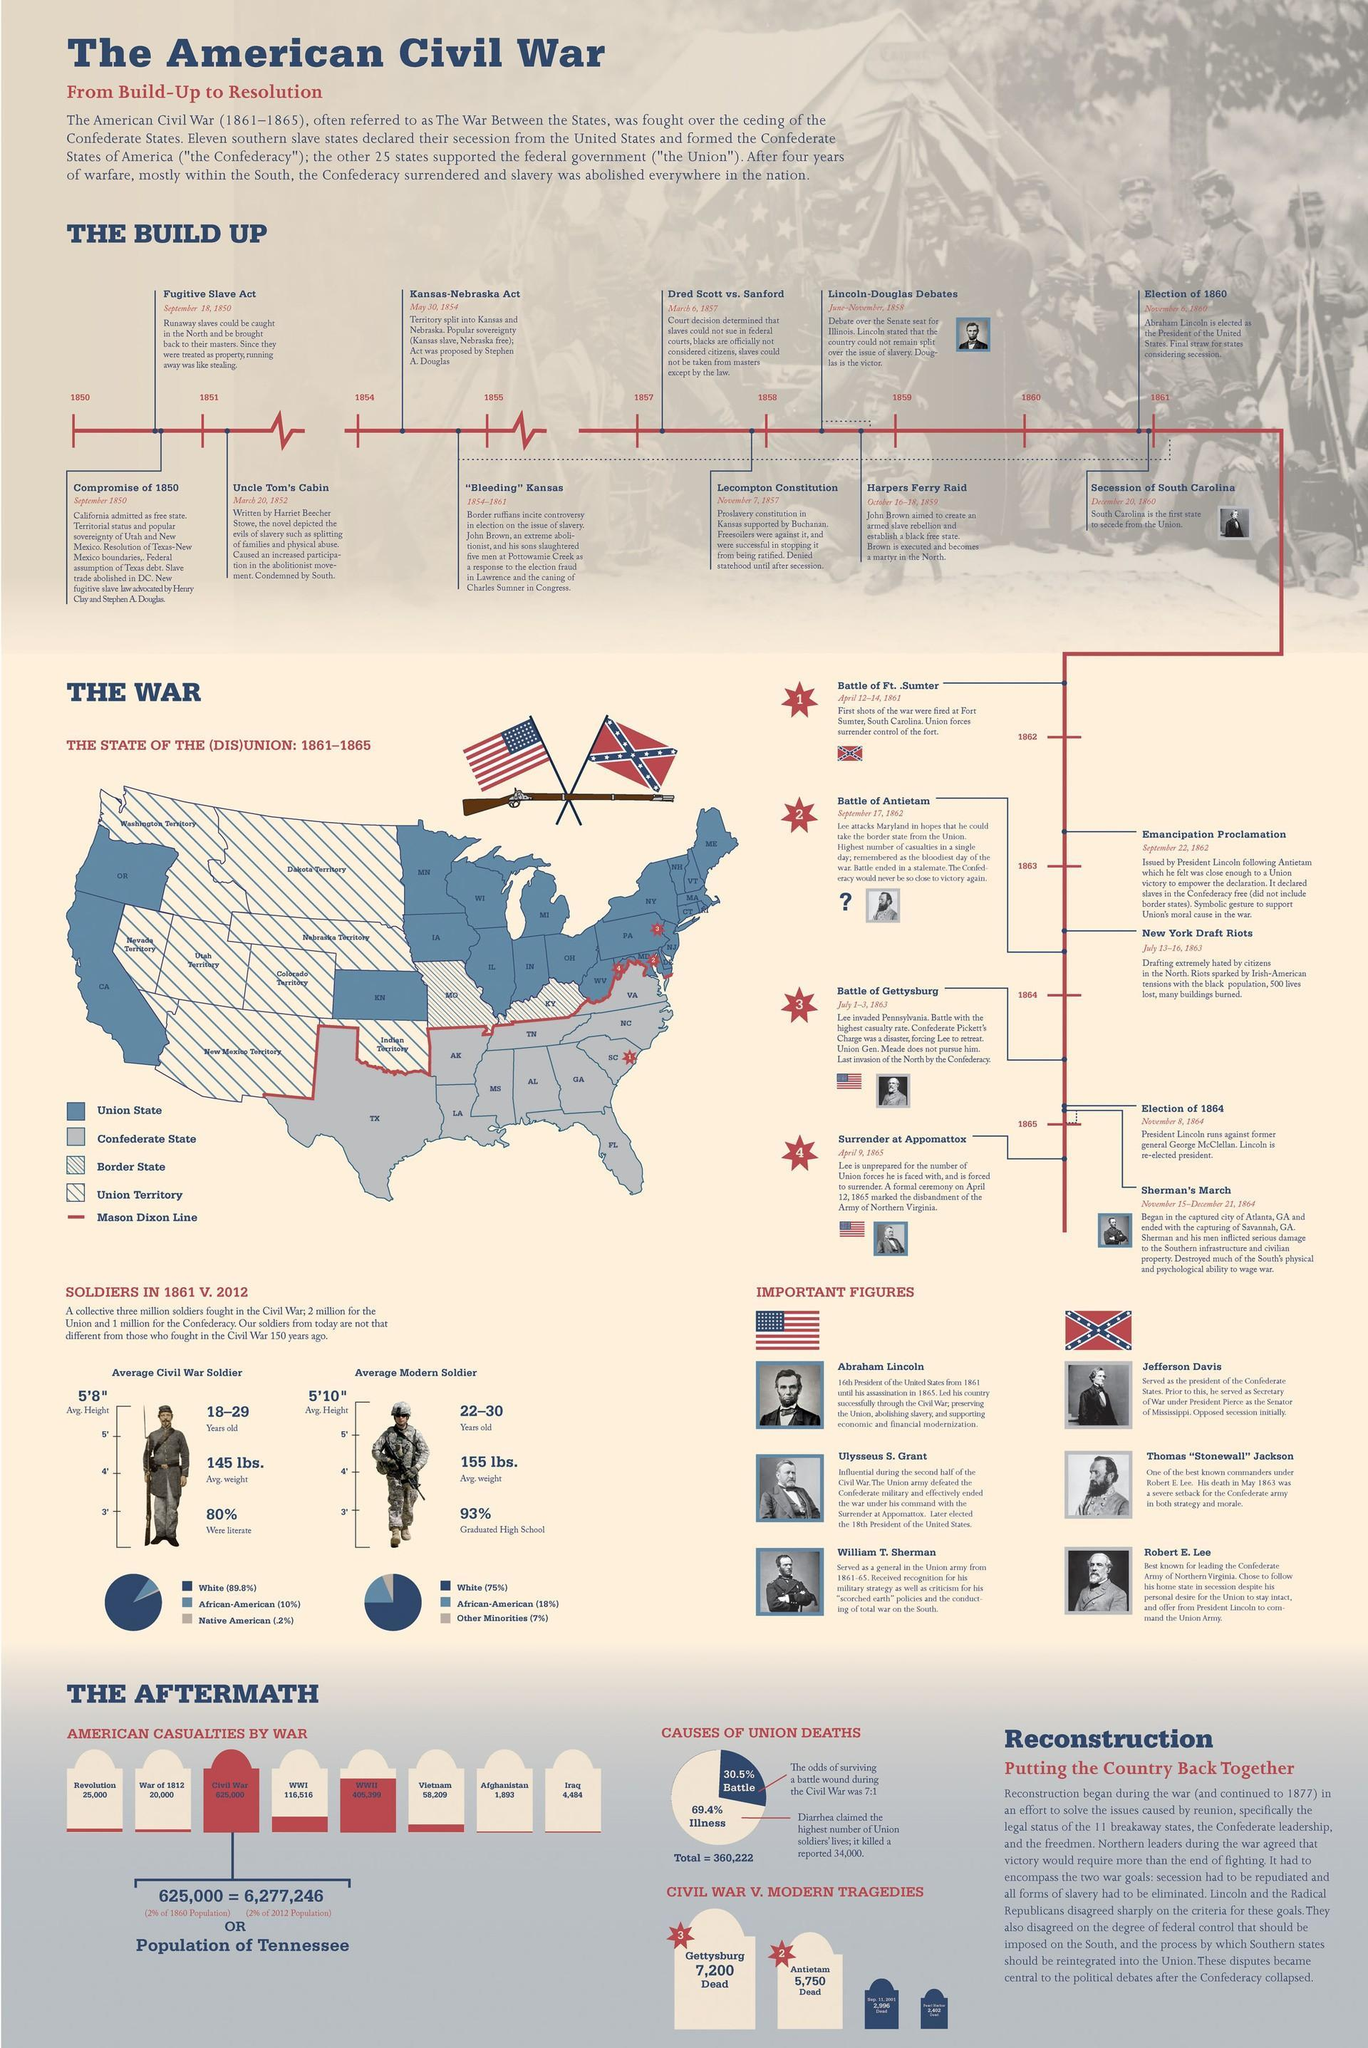How many American casualties were reported in the Vietnam War?
Answer the question with a short phrase. 58,209 What was the average weight of a Civil War soldier in 1861? 145 lbs. Which war had the most number of casualties in America? Civil War When did Abraham Lincoln become the president of America? 1861 When did South Carolina secede from the Union? December 20, 1860 What percent of modern soldiers are high school graduates in 2012? 93% How many American casualties were reported in the First World War? 116,516 Who is the author of Uncle Tom's Cabin? Harriet Beecher Stowe What was the average height of a Civil War soldier in 1861? 5'8" What percentage of modern soldiers are African-American in 2012? 18% 